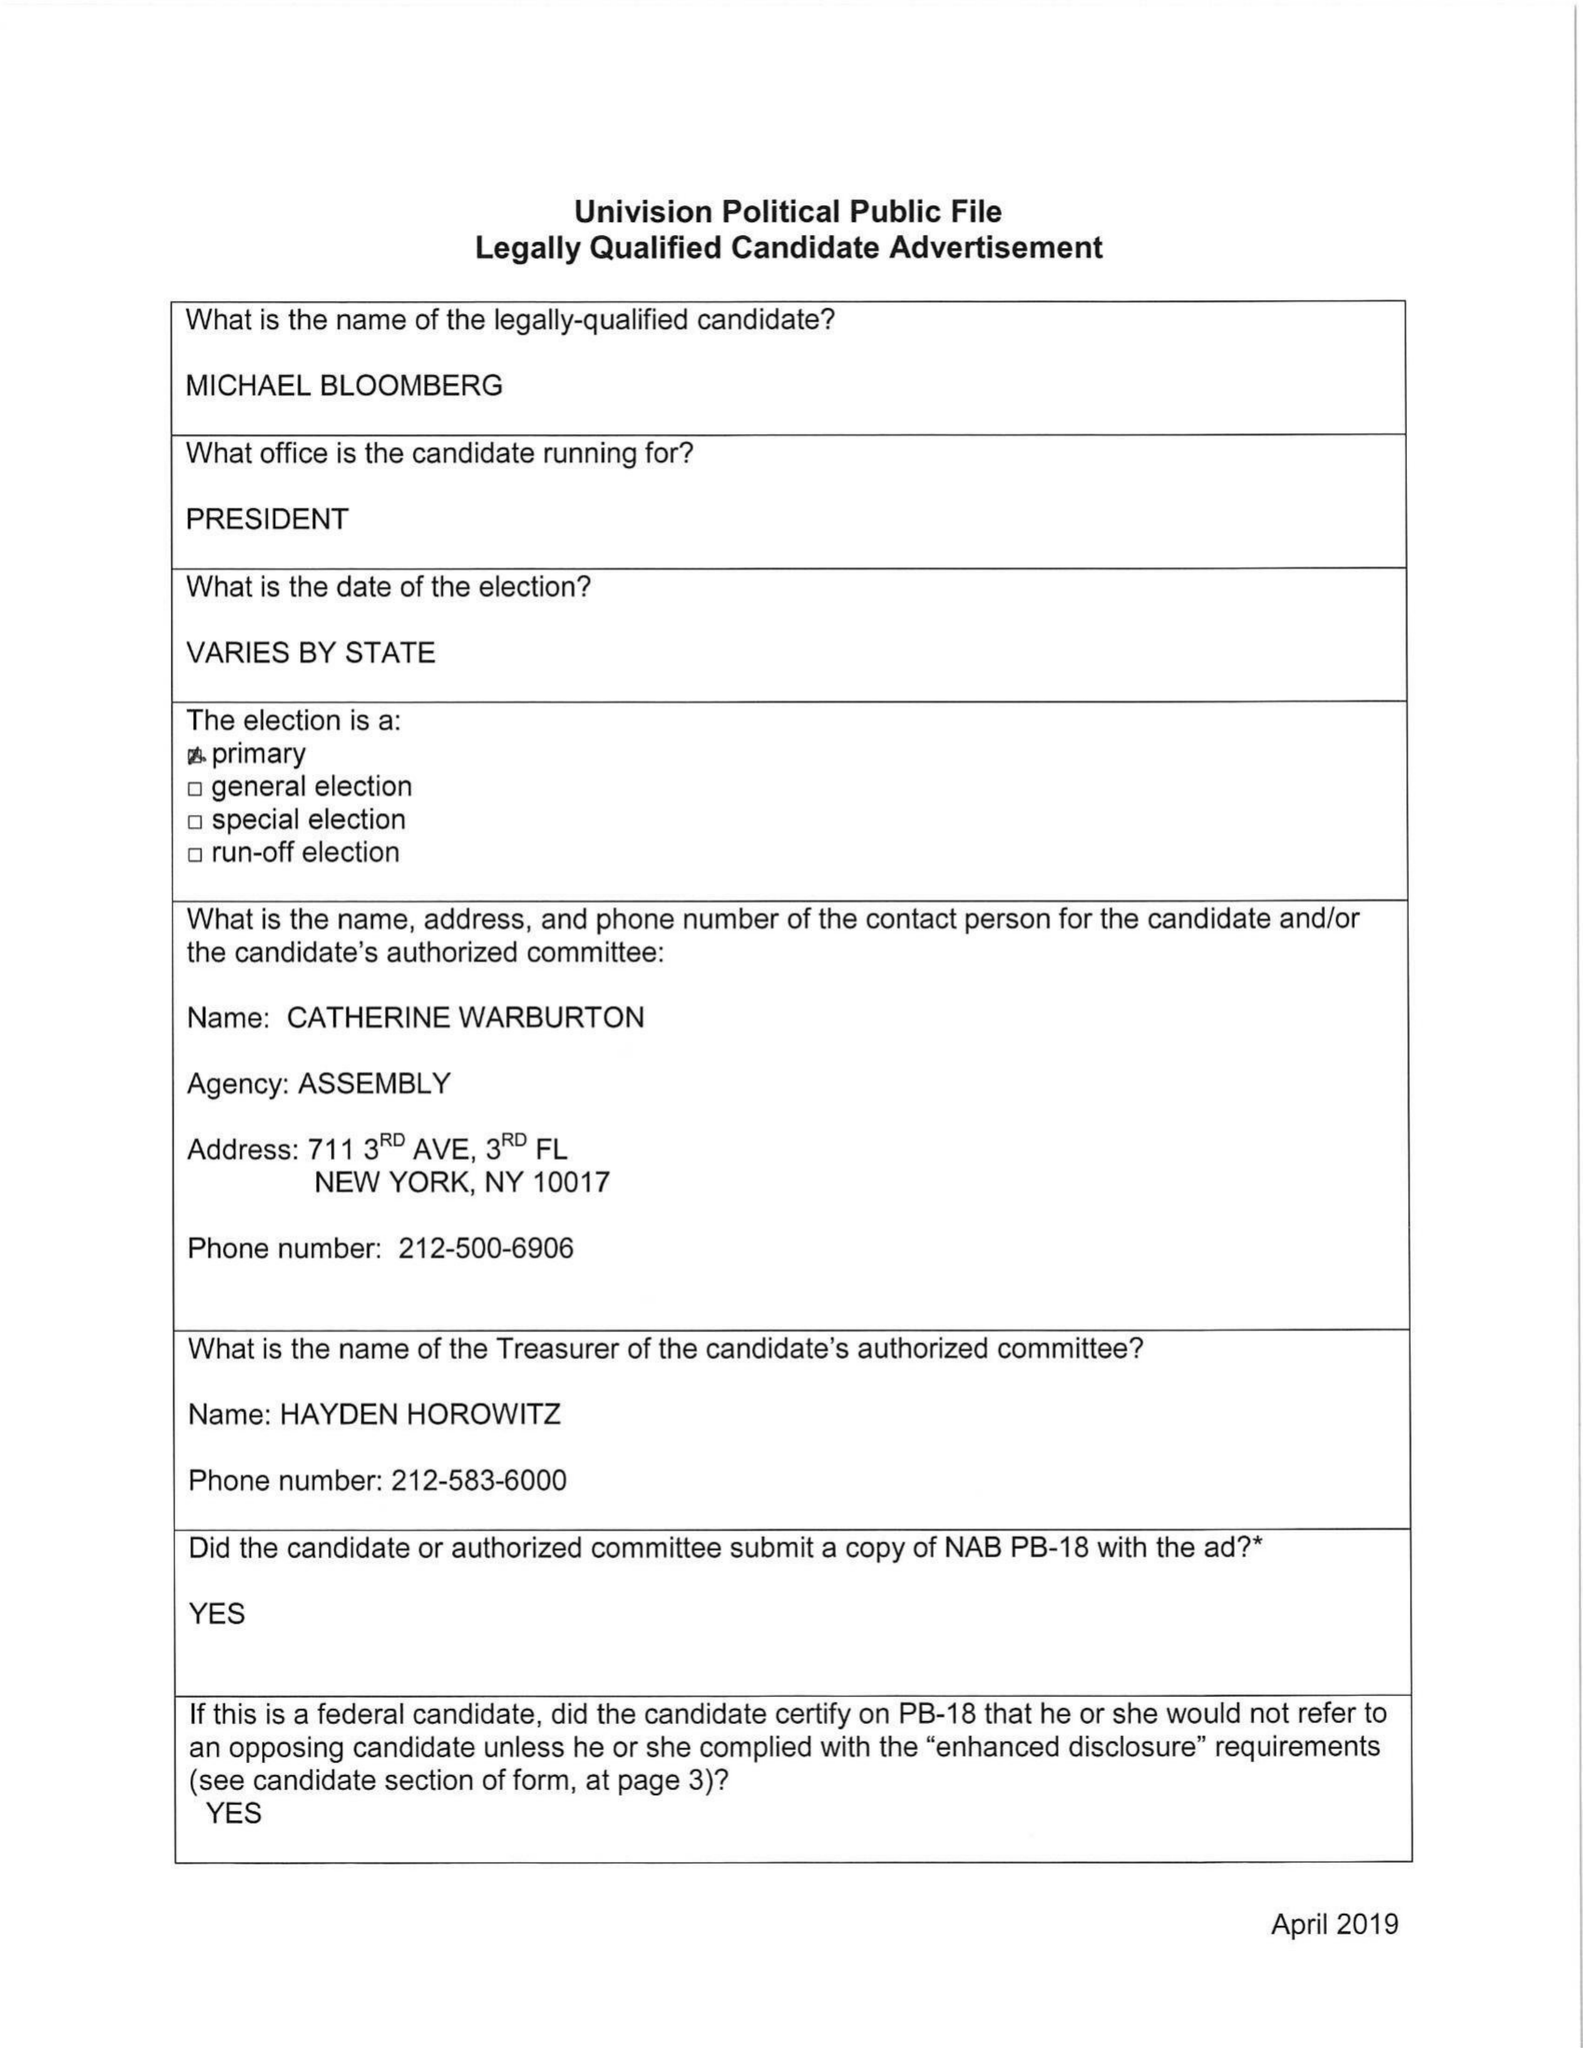What is the value for the contract_num?
Answer the question using a single word or phrase. None 